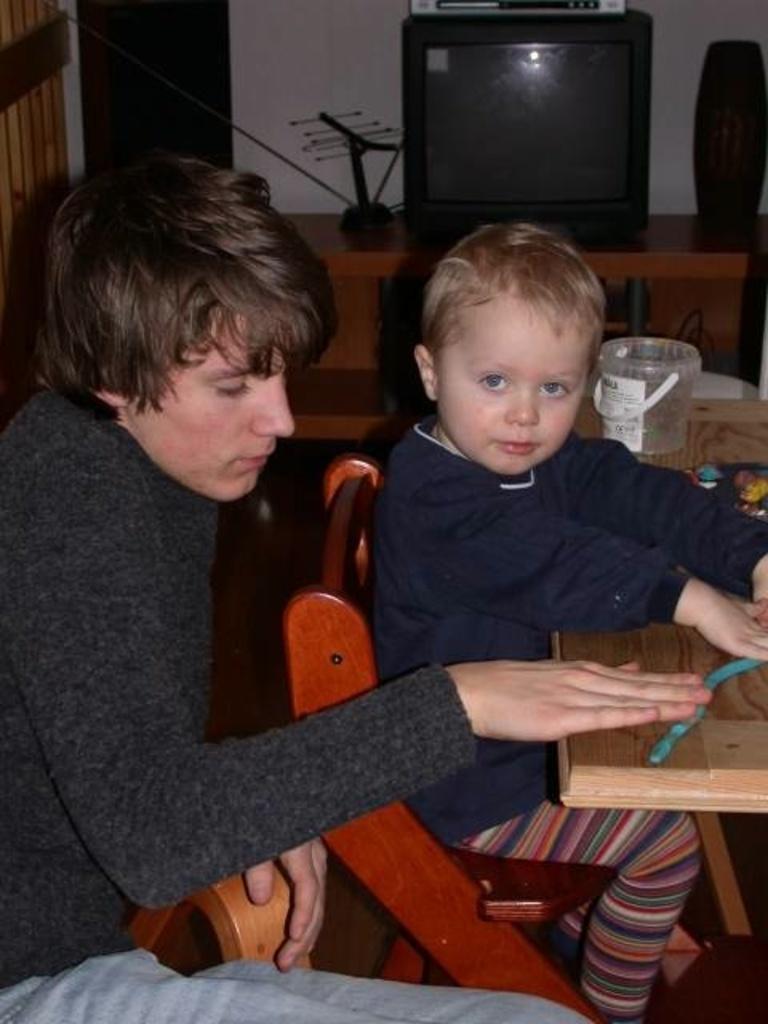Can you describe this image briefly? In this image we can see a child sitting on the chair near table and a person is sitting behind him. In the background we can see a television on the table. 